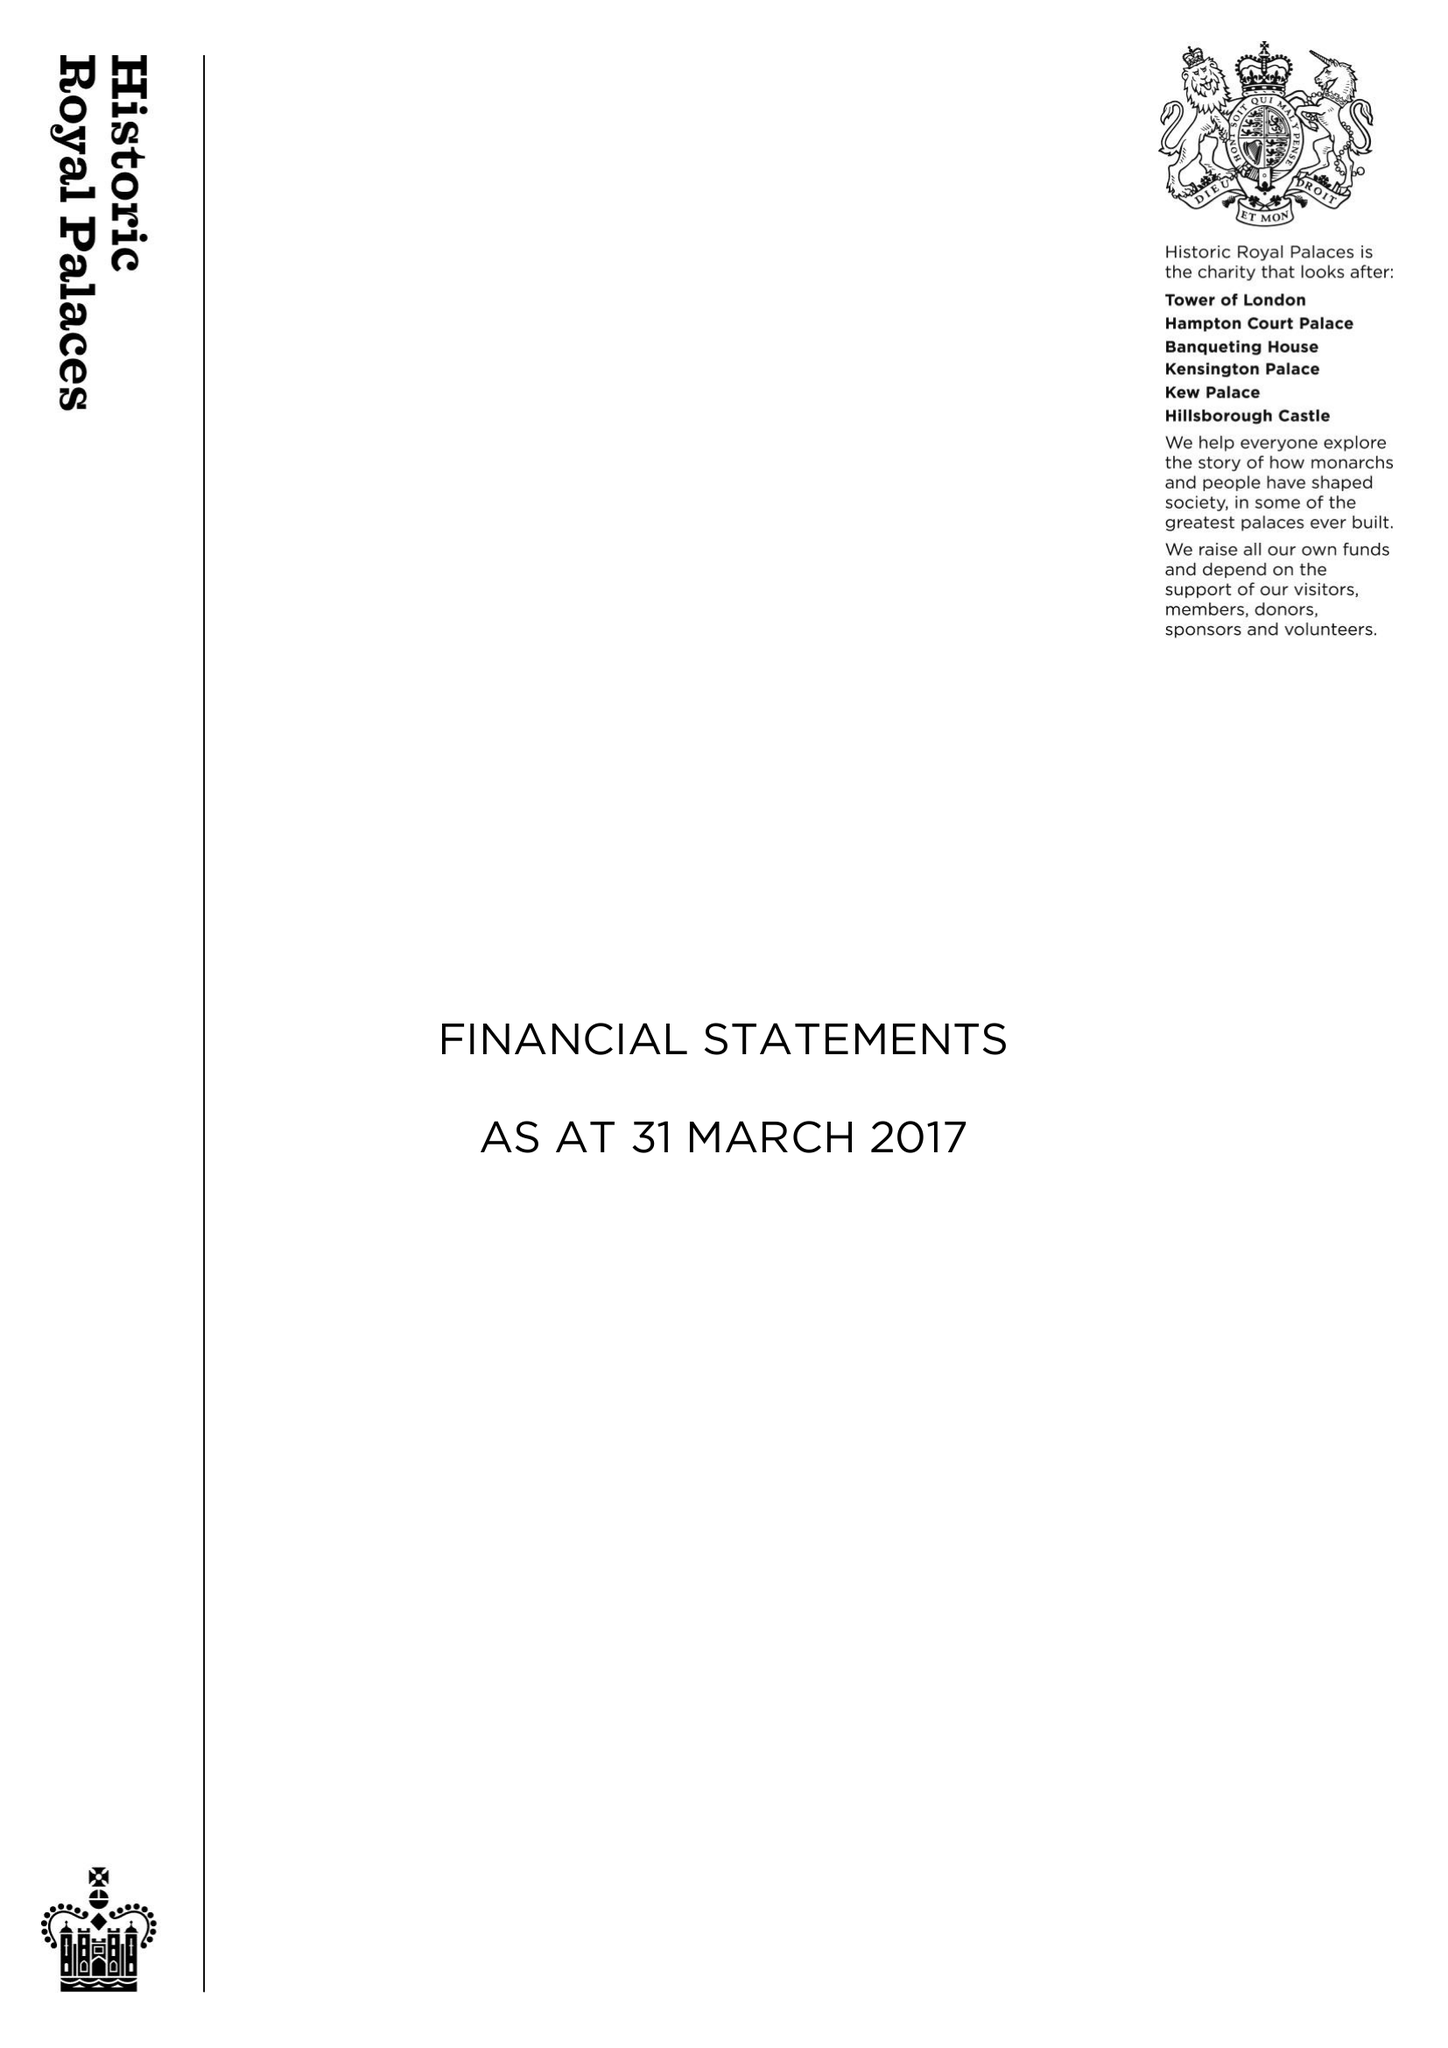What is the value for the address__street_line?
Answer the question using a single word or phrase. None 